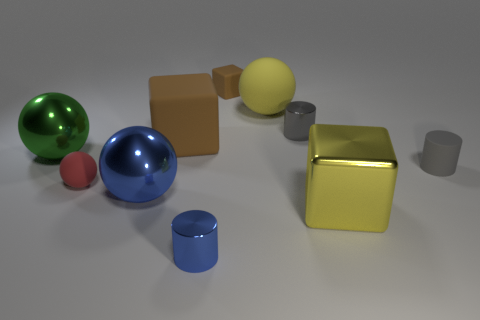How many objects are big cubes that are behind the small gray matte thing or yellow things behind the gray metal cylinder?
Provide a short and direct response. 2. The rubber cylinder that is the same size as the red sphere is what color?
Your answer should be very brief. Gray. Are the tiny red ball and the small blue cylinder made of the same material?
Give a very brief answer. No. There is a sphere that is to the right of the cylinder to the left of the tiny gray metal object; what is its material?
Keep it short and to the point. Rubber. Is the number of large green spheres to the right of the yellow sphere greater than the number of big blue objects?
Keep it short and to the point. No. What number of other objects are the same size as the blue cylinder?
Provide a short and direct response. 4. Do the small block and the big matte sphere have the same color?
Make the answer very short. No. There is a matte ball that is to the right of the big cube left of the rubber ball to the right of the big brown object; what is its color?
Give a very brief answer. Yellow. There is a tiny rubber thing that is behind the yellow thing behind the small red thing; what number of tiny brown cubes are in front of it?
Your response must be concise. 0. Are there any other things that are the same color as the small rubber sphere?
Your answer should be compact. No. 